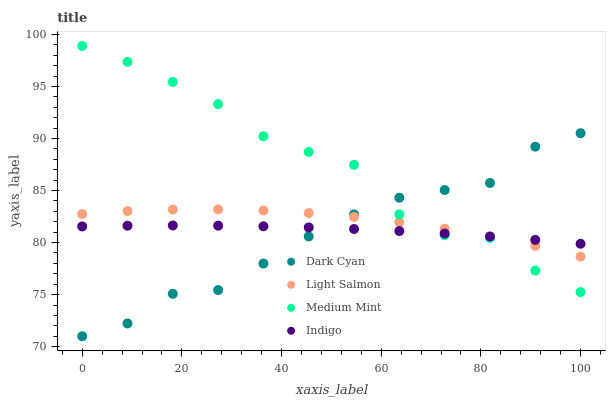Does Dark Cyan have the minimum area under the curve?
Answer yes or no. Yes. Does Medium Mint have the maximum area under the curve?
Answer yes or no. Yes. Does Light Salmon have the minimum area under the curve?
Answer yes or no. No. Does Light Salmon have the maximum area under the curve?
Answer yes or no. No. Is Indigo the smoothest?
Answer yes or no. Yes. Is Medium Mint the roughest?
Answer yes or no. Yes. Is Light Salmon the smoothest?
Answer yes or no. No. Is Light Salmon the roughest?
Answer yes or no. No. Does Dark Cyan have the lowest value?
Answer yes or no. Yes. Does Medium Mint have the lowest value?
Answer yes or no. No. Does Medium Mint have the highest value?
Answer yes or no. Yes. Does Light Salmon have the highest value?
Answer yes or no. No. Does Medium Mint intersect Dark Cyan?
Answer yes or no. Yes. Is Medium Mint less than Dark Cyan?
Answer yes or no. No. Is Medium Mint greater than Dark Cyan?
Answer yes or no. No. 